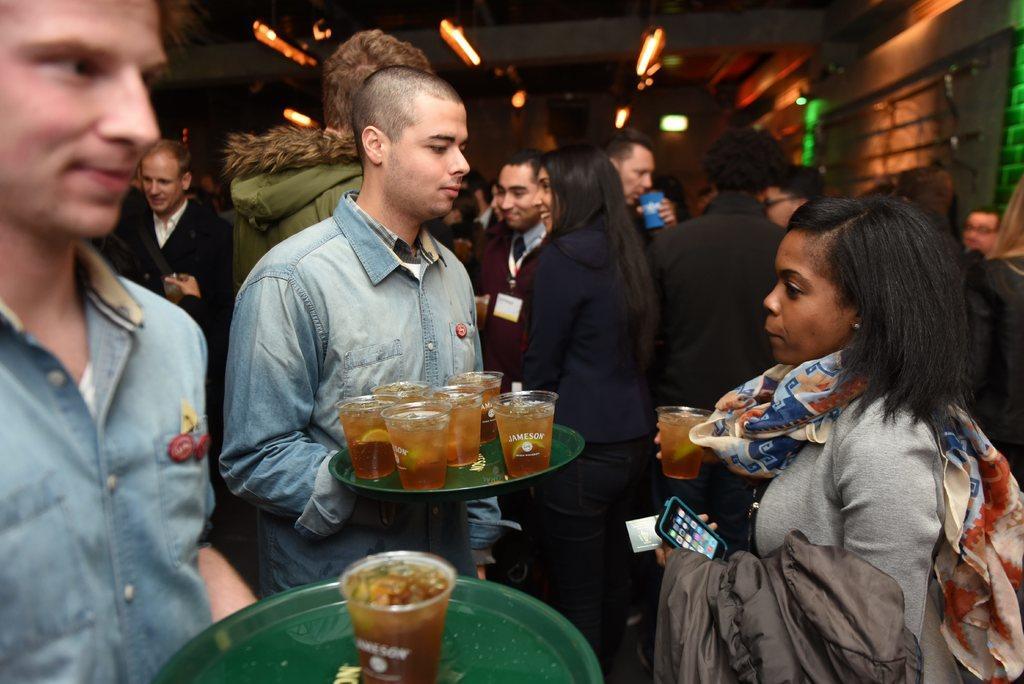Could you give a brief overview of what you see in this image? In this image i can see two man standing and holding few glasses in a hand at right the woman is holding a glass at the back ground i can see few persons standing at the top there is a light at right there is a wooden wall. 